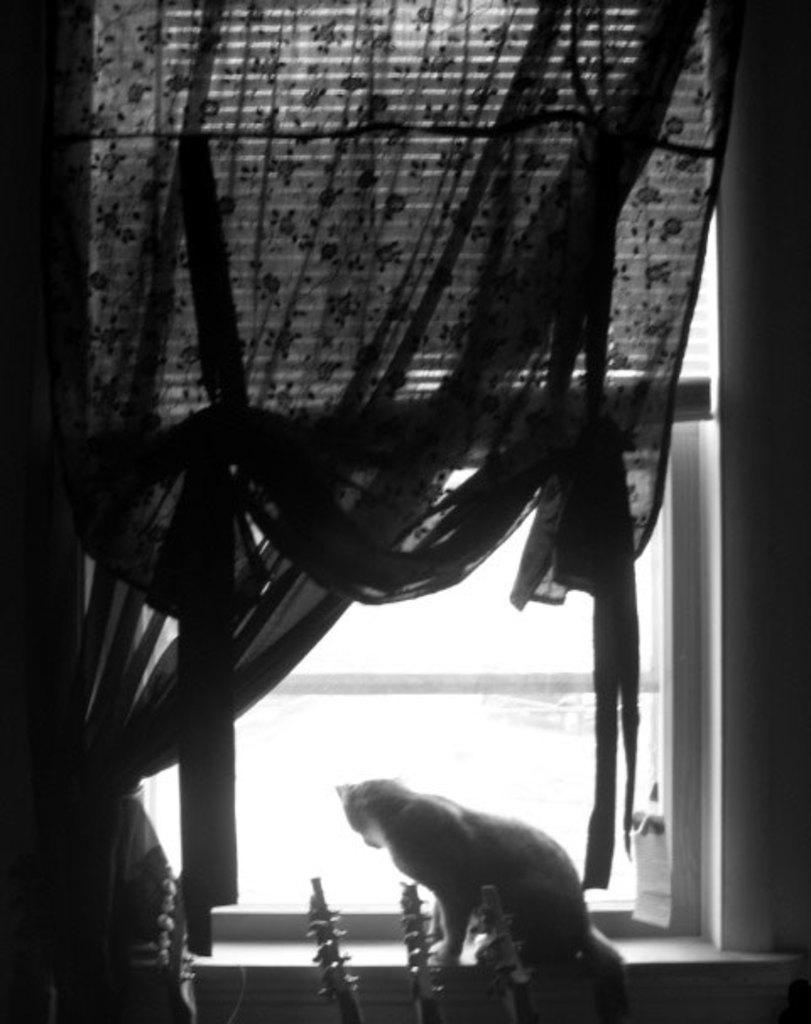What animal can be seen in the picture? There is a cat in the picture. Where is the cat located in relation to the window? The cat is sitting near a window. What can be seen in the window? There is a curtain visible in the window. How many times has the cat kicked a soccer ball in the image? There is no soccer ball present in the image, so the cat cannot kick one. 